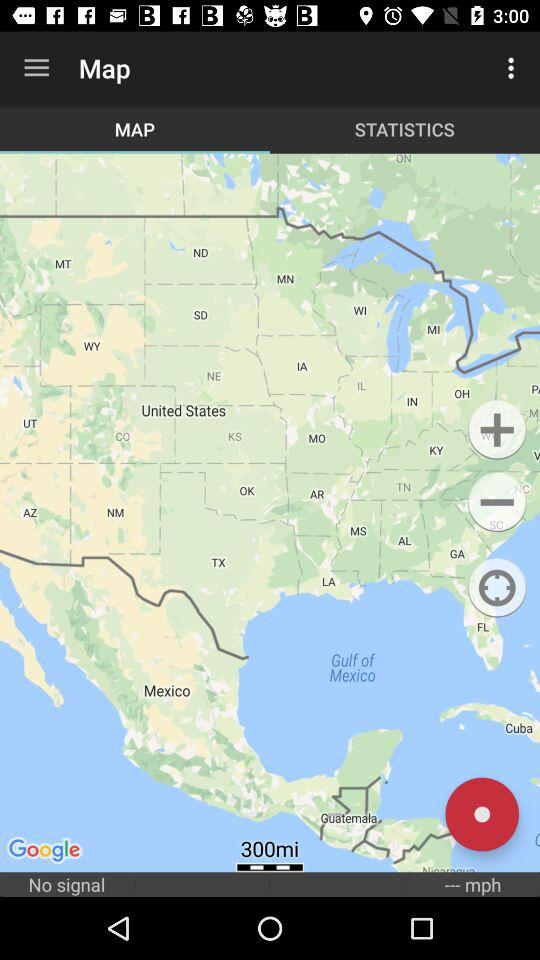Which tab is selected? The selected tab is "MAP". 